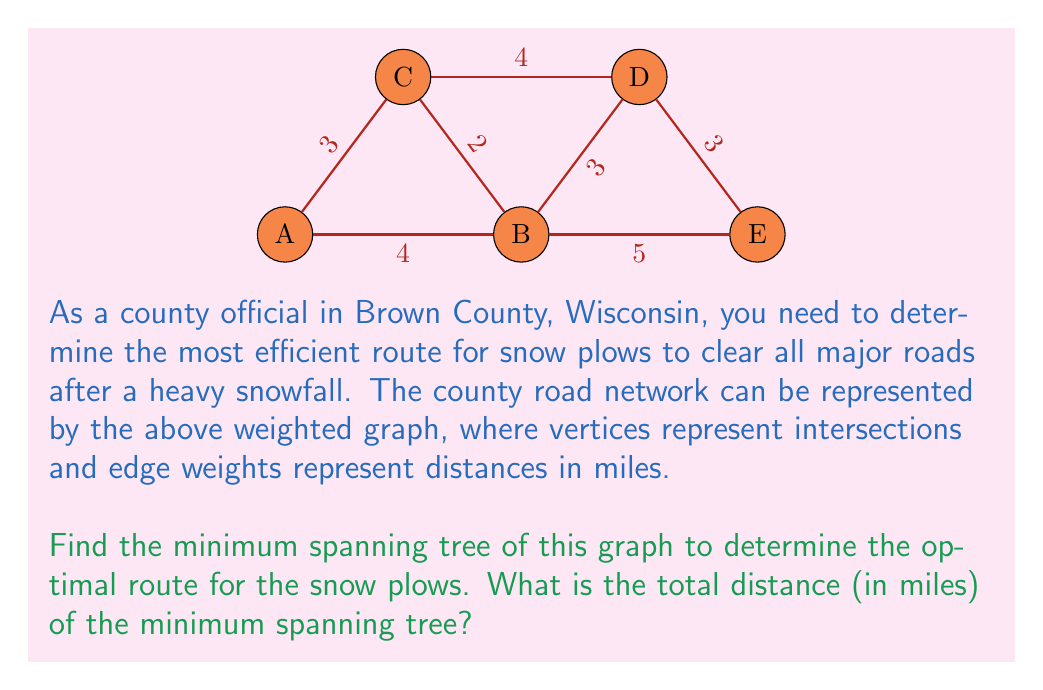Show me your answer to this math problem. To find the minimum spanning tree (MST) of this graph, we can use Kruskal's algorithm. This algorithm works by sorting all edges by weight and then adding them to the MST if they don't create a cycle. Here's the step-by-step process:

1. Sort all edges by weight:
   $AB: 4, BE: 5, AC: 3, BC: 2, CD: 4, DE: 3, BD: 3$

2. Start with the smallest edge: $BC (2)$
   MST: $BC$
   Total distance: 2 miles

3. Next smallest edge: $AC (3)$
   MST: $BC, AC$
   Total distance: 5 miles

4. Next: $BD (3)$
   MST: $BC, AC, BD$
   Total distance: 8 miles

5. Next: $DE (3)$
   MST: $BC, AC, BD, DE$
   Total distance: 11 miles

6. The next edge $AB (4)$ would create a cycle, so we skip it.
   The same applies to $CD (4)$ and $BE (5)$.

The algorithm terminates here as we have included all vertices in our MST.

The resulting minimum spanning tree consists of edges $BC, AC, BD,$ and $DE$, with a total distance of 11 miles.
Answer: 11 miles 